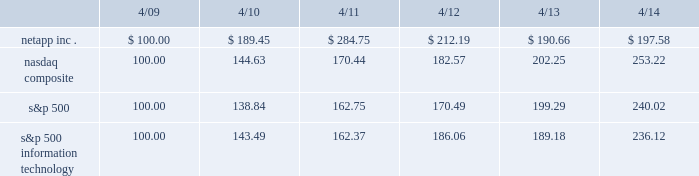Performance graph the following graph shows a five-year comparison of the cumulative total return on our common stock , the nasdaq composite index , the s&p 500 index and the s&p 500 information technology index from april 24 , 2009 through april 25 , 2014 .
The past performance of our common stock is not indicative of the future performance of our common stock .
Comparison of 5 year cumulative total return* among netapp , inc. , the nasdaq composite index , the s&p 500 index and the s&p 500 information technology index .
We believe that a number of factors may cause the market price of our common stock to fluctuate significantly .
See 201citem 1a .
Risk factors . 201d sale of unregistered securities .
What was the difference in percentage cumulative total return for the five year period ending 4/14 between netapp inc . and the s&p 500 information technology index? 
Computations: ((197.58 - 100) - (236.12 - 100))
Answer: -38.54. Performance graph the following graph shows a five-year comparison of the cumulative total return on our common stock , the nasdaq composite index , the s&p 500 index and the s&p 500 information technology index from april 24 , 2009 through april 25 , 2014 .
The past performance of our common stock is not indicative of the future performance of our common stock .
Comparison of 5 year cumulative total return* among netapp , inc. , the nasdaq composite index , the s&p 500 index and the s&p 500 information technology index .
We believe that a number of factors may cause the market price of our common stock to fluctuate significantly .
See 201citem 1a .
Risk factors . 201d sale of unregistered securities .
What was the difference in percentage cumulative total return for the five year period ending 4/14 between netapp inc . and the nasdaq composite? 
Computations: (((197.58 - 100) / 100) - ((253.22 - 100) / 100))
Answer: -0.5564. 